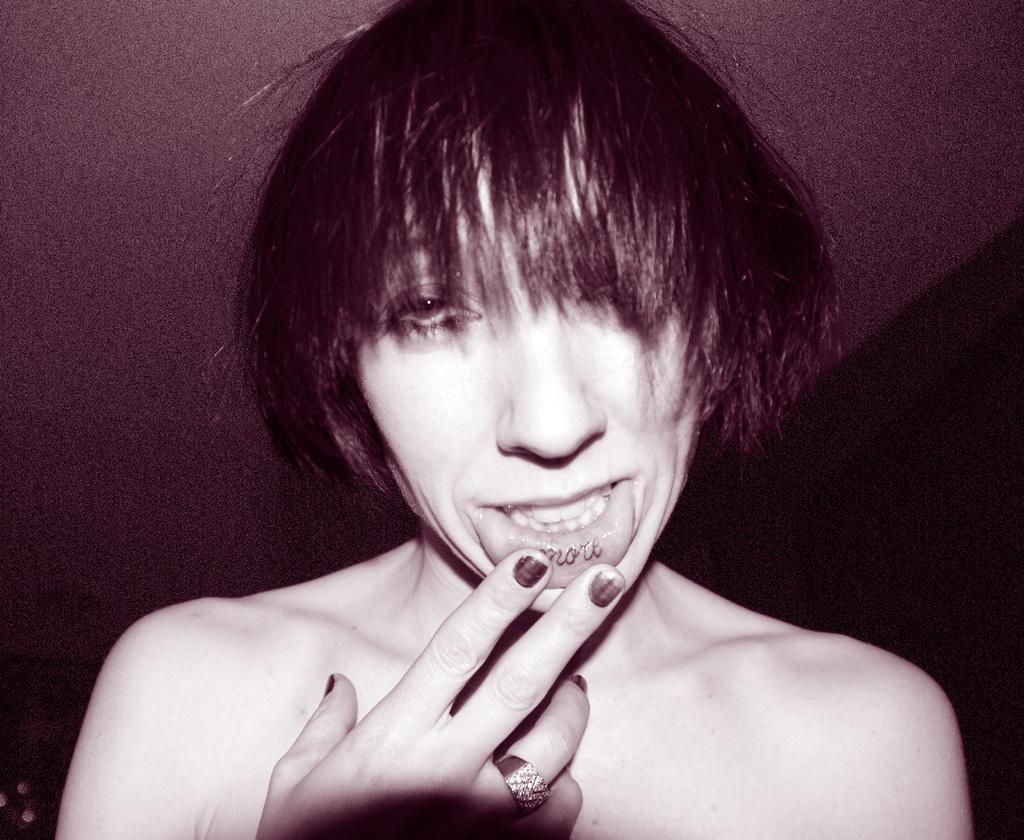In one or two sentences, can you explain what this image depicts? In this image we can see a woman keeping her fingers on the lips. 